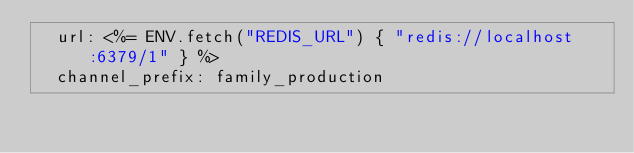Convert code to text. <code><loc_0><loc_0><loc_500><loc_500><_YAML_>  url: <%= ENV.fetch("REDIS_URL") { "redis://localhost:6379/1" } %>
  channel_prefix: family_production
</code> 